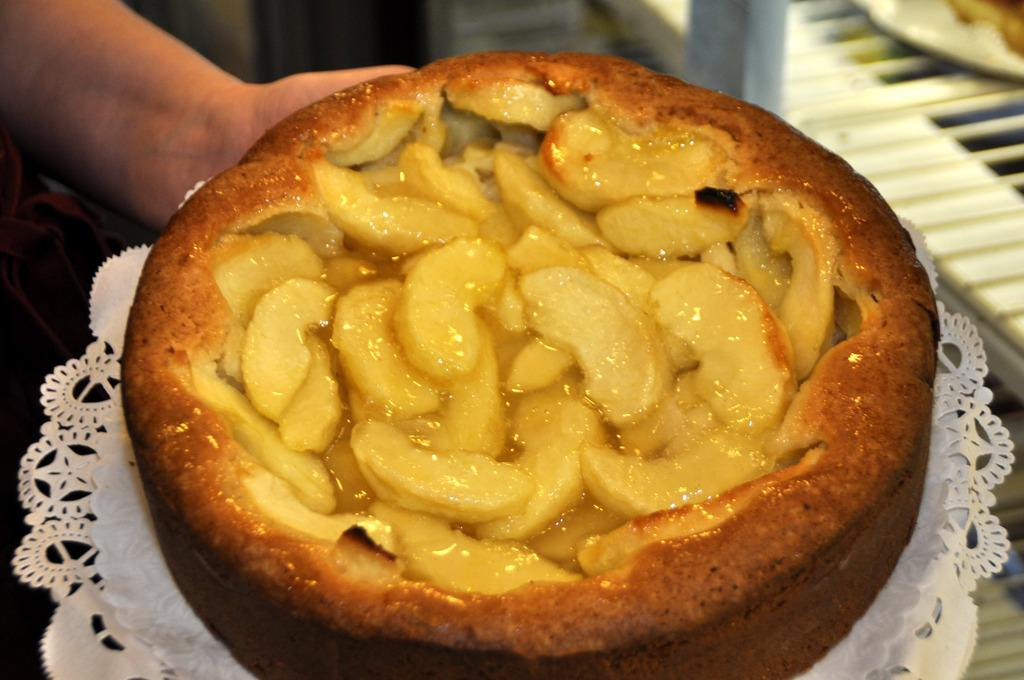What is on the plate that is visible in the image? There is a plate with cake in the image. What is being held by someone in the image? There is a cloth held in someone's hand. How would you describe the background of the image? The background of the image is blurry. What can be seen on a platform in the background? There is an object on a platform in the background. What type of trail can be seen in the image? There is no trail present in the image. What color is the copper object on the platform in the background? There is no copper object present in the image. 